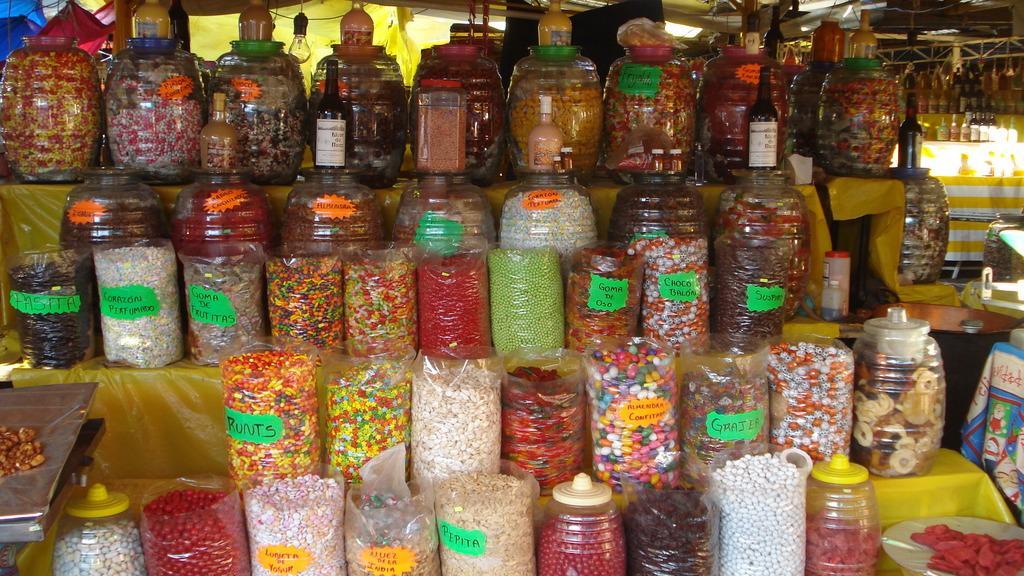Can you describe this image briefly? In the picture I can see the bottles, Inside the bottles I can see eatable items. 